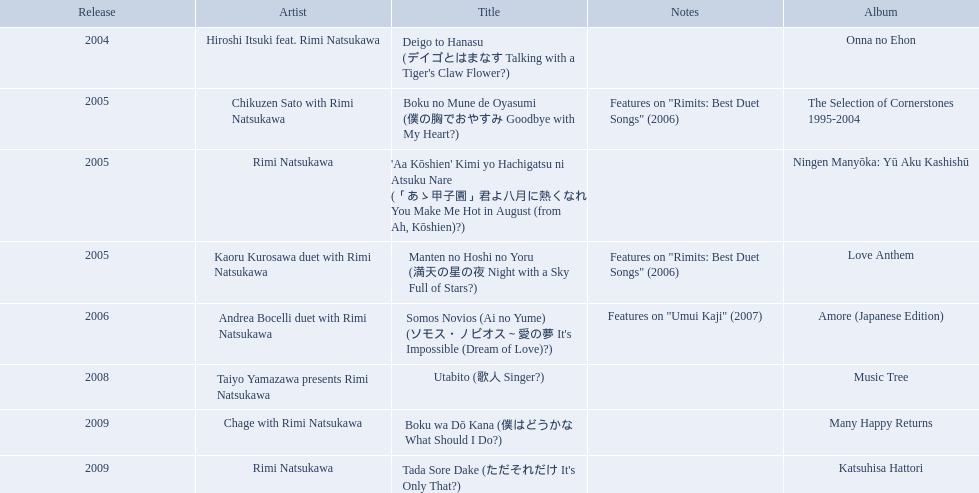What are the names of each album by rimi natsukawa? Onna no Ehon, The Selection of Cornerstones 1995-2004, Ningen Manyōka: Yū Aku Kashishū, Love Anthem, Amore (Japanese Edition), Music Tree, Many Happy Returns, Katsuhisa Hattori. Parse the full table. {'header': ['Release', 'Artist', 'Title', 'Notes', 'Album'], 'rows': [['2004', 'Hiroshi Itsuki feat. Rimi Natsukawa', "Deigo to Hanasu (デイゴとはまなす Talking with a Tiger's Claw Flower?)", '', 'Onna no Ehon'], ['2005', 'Chikuzen Sato with Rimi Natsukawa', 'Boku no Mune de Oyasumi (僕の胸でおやすみ Goodbye with My Heart?)', 'Features on "Rimits: Best Duet Songs" (2006)', 'The Selection of Cornerstones 1995-2004'], ['2005', 'Rimi Natsukawa', "'Aa Kōshien' Kimi yo Hachigatsu ni Atsuku Nare (「あゝ甲子園」君よ八月に熱くなれ You Make Me Hot in August (from Ah, Kōshien)?)", '', 'Ningen Manyōka: Yū Aku Kashishū'], ['2005', 'Kaoru Kurosawa duet with Rimi Natsukawa', 'Manten no Hoshi no Yoru (満天の星の夜 Night with a Sky Full of Stars?)', 'Features on "Rimits: Best Duet Songs" (2006)', 'Love Anthem'], ['2006', 'Andrea Bocelli duet with Rimi Natsukawa', "Somos Novios (Ai no Yume) (ソモス・ノビオス～愛の夢 It's Impossible (Dream of Love)?)", 'Features on "Umui Kaji" (2007)', 'Amore (Japanese Edition)'], ['2008', 'Taiyo Yamazawa presents Rimi Natsukawa', 'Utabito (歌人 Singer?)', '', 'Music Tree'], ['2009', 'Chage with Rimi Natsukawa', 'Boku wa Dō Kana (僕はどうかな What Should I Do?)', '', 'Many Happy Returns'], ['2009', 'Rimi Natsukawa', "Tada Sore Dake (ただそれだけ It's Only That?)", '', 'Katsuhisa Hattori']]} And when were the albums released? 2004, 2005, 2005, 2005, 2006, 2008, 2009, 2009. Was onna no ehon or music tree released most recently? Music Tree. What year was onna no ehon released? 2004. What year was music tree released? 2008. Which of the two was not released in 2004? Music Tree. When was onna no ehon released? 2004. When was the selection of cornerstones 1995-2004 released? 2005. What was released in 2008? Music Tree. What are all the names of the titles? Deigo to Hanasu (デイゴとはまなす Talking with a Tiger's Claw Flower?), Boku no Mune de Oyasumi (僕の胸でおやすみ Goodbye with My Heart?), 'Aa Kōshien' Kimi yo Hachigatsu ni Atsuku Nare (「あゝ甲子園」君よ八月に熱くなれ You Make Me Hot in August (from Ah, Kōshien)?), Manten no Hoshi no Yoru (満天の星の夜 Night with a Sky Full of Stars?), Somos Novios (Ai no Yume) (ソモス・ノビオス～愛の夢 It's Impossible (Dream of Love)?), Utabito (歌人 Singer?), Boku wa Dō Kana (僕はどうかな What Should I Do?), Tada Sore Dake (ただそれだけ It's Only That?). What are their remarks? , Features on "Rimits: Best Duet Songs" (2006), , Features on "Rimits: Best Duet Songs" (2006), Features on "Umui Kaji" (2007), , , . Which title contains the same notes as "manten no hoshi no yoru" (man tian noxing noye night with a sky full of stars)? Boku no Mune de Oyasumi (僕の胸でおやすみ Goodbye with My Heart?). 